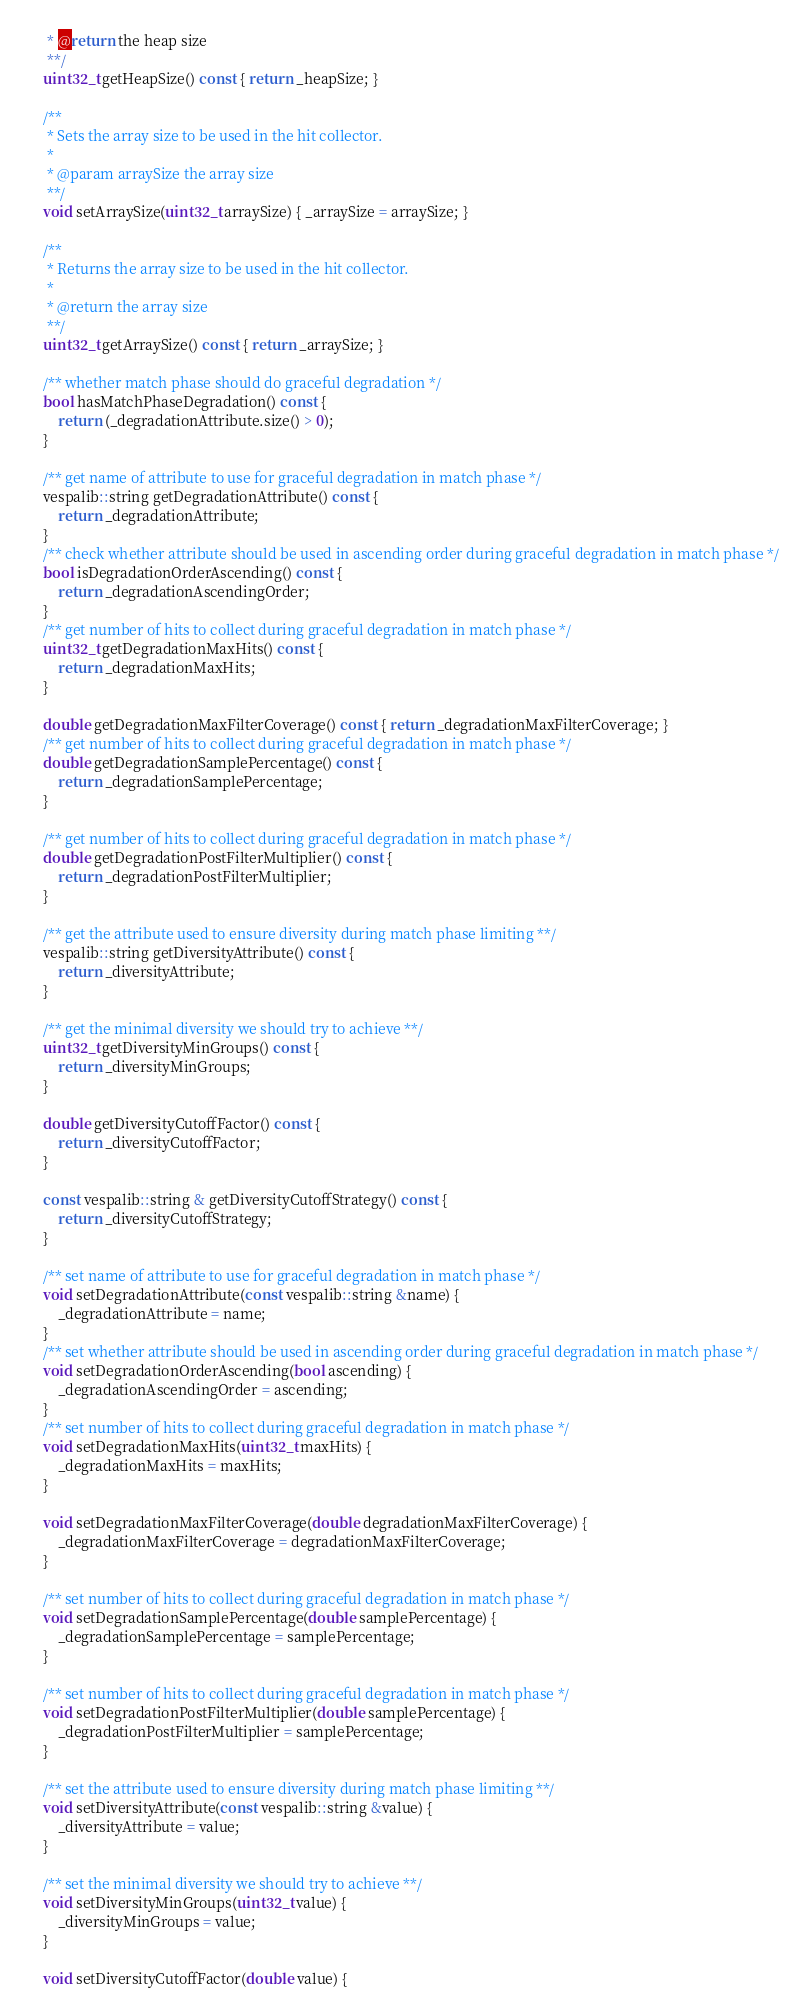Convert code to text. <code><loc_0><loc_0><loc_500><loc_500><_C_>     * @return the heap size
     **/
    uint32_t getHeapSize() const { return _heapSize; }

    /**
     * Sets the array size to be used in the hit collector.
     *
     * @param arraySize the array size
     **/
    void setArraySize(uint32_t arraySize) { _arraySize = arraySize; }

    /**
     * Returns the array size to be used in the hit collector.
     *
     * @return the array size
     **/
    uint32_t getArraySize() const { return _arraySize; }

    /** whether match phase should do graceful degradation */
    bool hasMatchPhaseDegradation() const {
        return (_degradationAttribute.size() > 0);
    }

    /** get name of attribute to use for graceful degradation in match phase */
    vespalib::string getDegradationAttribute() const {
        return _degradationAttribute;
    }
    /** check whether attribute should be used in ascending order during graceful degradation in match phase */
    bool isDegradationOrderAscending() const {
        return _degradationAscendingOrder;
    }
    /** get number of hits to collect during graceful degradation in match phase */
    uint32_t getDegradationMaxHits() const {
        return _degradationMaxHits;
    }

    double getDegradationMaxFilterCoverage() const { return _degradationMaxFilterCoverage; }
    /** get number of hits to collect during graceful degradation in match phase */
    double getDegradationSamplePercentage() const {
        return _degradationSamplePercentage;
    }

    /** get number of hits to collect during graceful degradation in match phase */
    double getDegradationPostFilterMultiplier() const {
        return _degradationPostFilterMultiplier;
    }

    /** get the attribute used to ensure diversity during match phase limiting **/
    vespalib::string getDiversityAttribute() const {
        return _diversityAttribute;
    }

    /** get the minimal diversity we should try to achieve **/
    uint32_t getDiversityMinGroups() const {
        return _diversityMinGroups;
    }

    double getDiversityCutoffFactor() const {
        return _diversityCutoffFactor;
    }

    const vespalib::string & getDiversityCutoffStrategy() const {
        return _diversityCutoffStrategy;
    }

    /** set name of attribute to use for graceful degradation in match phase */
    void setDegradationAttribute(const vespalib::string &name) {
        _degradationAttribute = name;
    }
    /** set whether attribute should be used in ascending order during graceful degradation in match phase */
    void setDegradationOrderAscending(bool ascending) {
        _degradationAscendingOrder = ascending;
    }
    /** set number of hits to collect during graceful degradation in match phase */
    void setDegradationMaxHits(uint32_t maxHits) {
        _degradationMaxHits = maxHits;
    }

    void setDegradationMaxFilterCoverage(double degradationMaxFilterCoverage) {
        _degradationMaxFilterCoverage = degradationMaxFilterCoverage;
    }

    /** set number of hits to collect during graceful degradation in match phase */
    void setDegradationSamplePercentage(double samplePercentage) {
        _degradationSamplePercentage = samplePercentage;
    }

    /** set number of hits to collect during graceful degradation in match phase */
    void setDegradationPostFilterMultiplier(double samplePercentage) {
        _degradationPostFilterMultiplier = samplePercentage;
    }

    /** set the attribute used to ensure diversity during match phase limiting **/
    void setDiversityAttribute(const vespalib::string &value) {
        _diversityAttribute = value;
    }

    /** set the minimal diversity we should try to achieve **/
    void setDiversityMinGroups(uint32_t value) {
        _diversityMinGroups = value;
    }

    void setDiversityCutoffFactor(double value) {</code> 